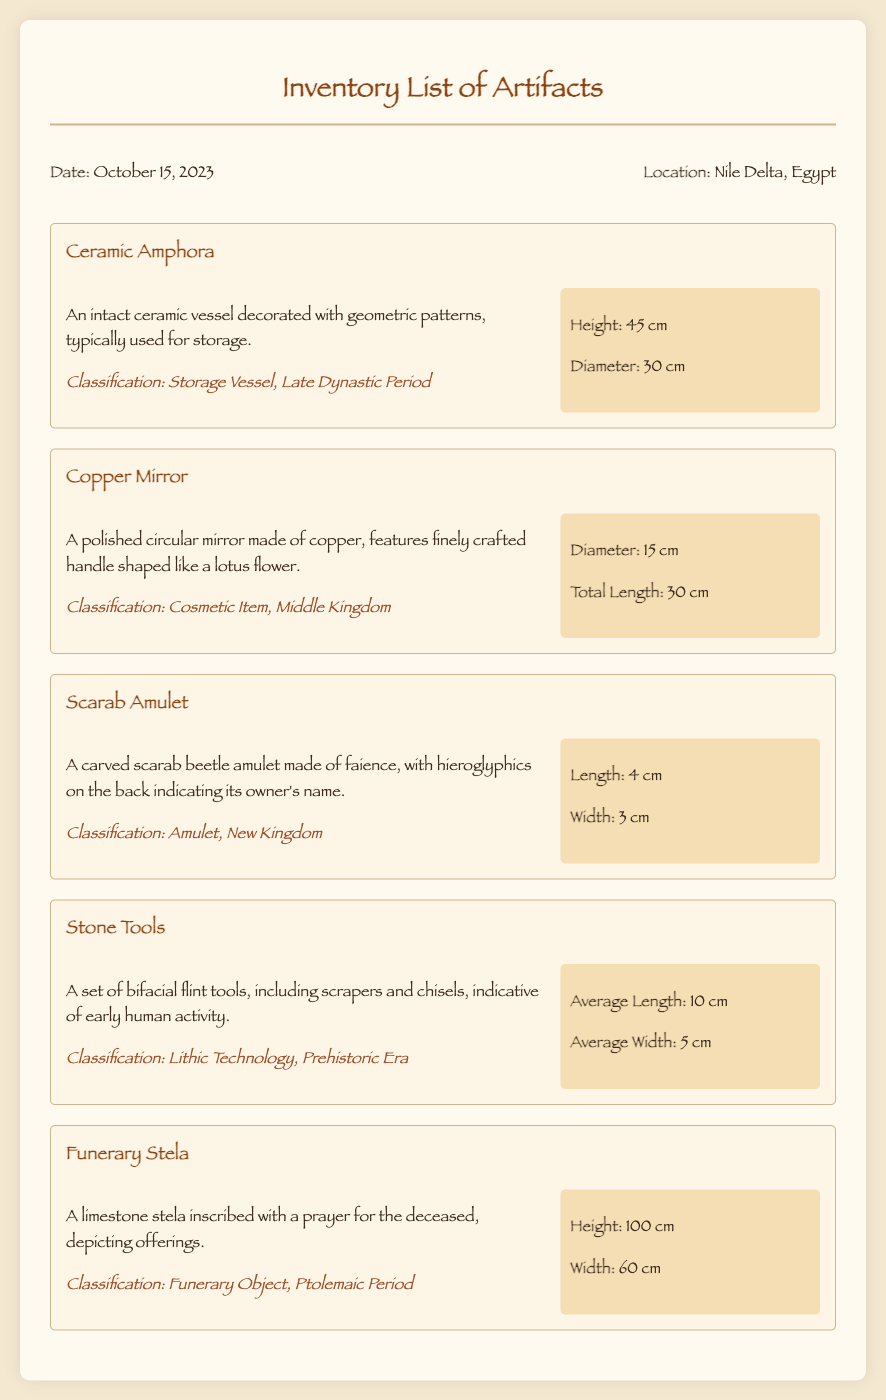what is the date of the memo? The memo lists the date at the beginning, which is October 15, 2023.
Answer: October 15, 2023 where was the excavation located? The location of the excavation is mentioned in the header of the memo as Nile Delta, Egypt.
Answer: Nile Delta, Egypt how tall is the funerary stela? The height of the funerary stela is specified in the artifact section as 100 cm.
Answer: 100 cm what material is the copper mirror made of? The description of the copper mirror states that it is made of polished copper.
Answer: polished copper which artifact is classified as a storage vessel? The artifact section describes the ceramic amphora as a storage vessel from the Late Dynastic Period.
Answer: Ceramic Amphora what period does the scarab amulet belong to? The classification for the scarab amulet indicates it belongs to the New Kingdom period.
Answer: New Kingdom how many artifacts are listed in the memo? The memo enumerates five distinct artifacts discovered during the excavation.
Answer: five which artifact features a handle shaped like a lotus flower? The description of the copper mirror states that it has a finely crafted handle in the shape of a lotus flower.
Answer: Copper Mirror what is the average width of the stone tools? The measurements of the stone tools detail the average width as 5 cm.
Answer: 5 cm 